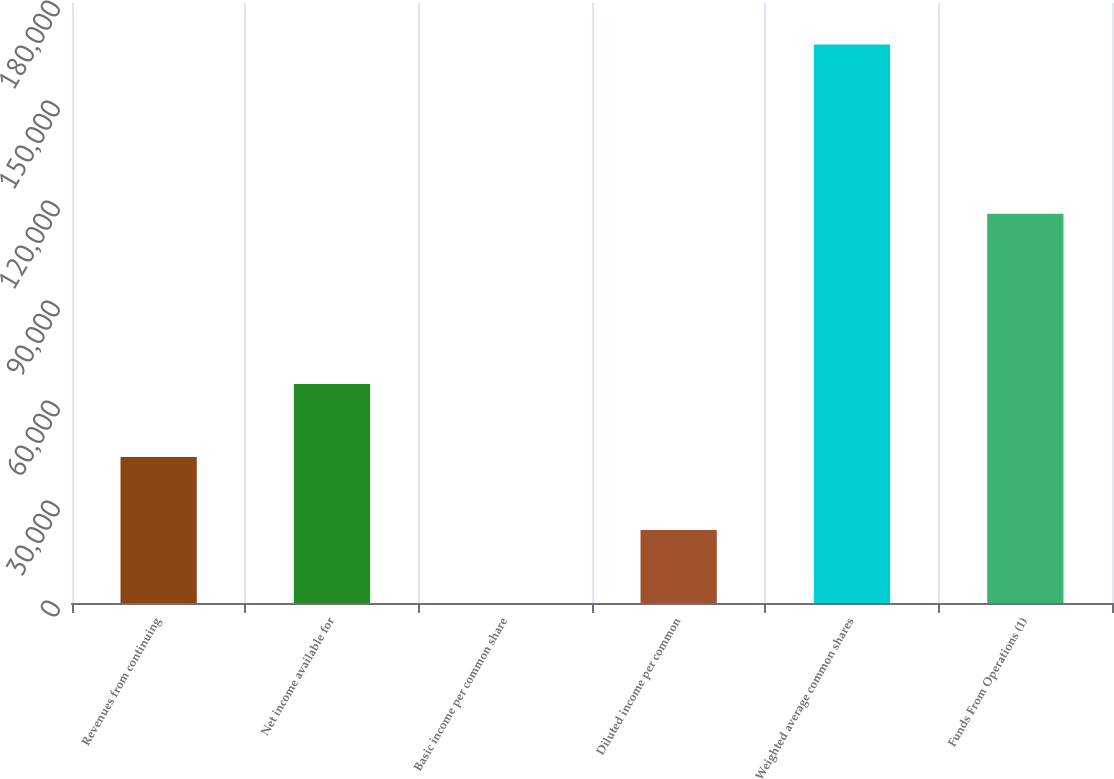Convert chart to OTSL. <chart><loc_0><loc_0><loc_500><loc_500><bar_chart><fcel>Revenues from continuing<fcel>Net income available for<fcel>Basic income per common share<fcel>Diluted income per common<fcel>Weighted average common shares<fcel>Funds From Operations (1)<nl><fcel>43813.9<fcel>65720.7<fcel>0.4<fcel>21907.2<fcel>167530<fcel>116750<nl></chart> 